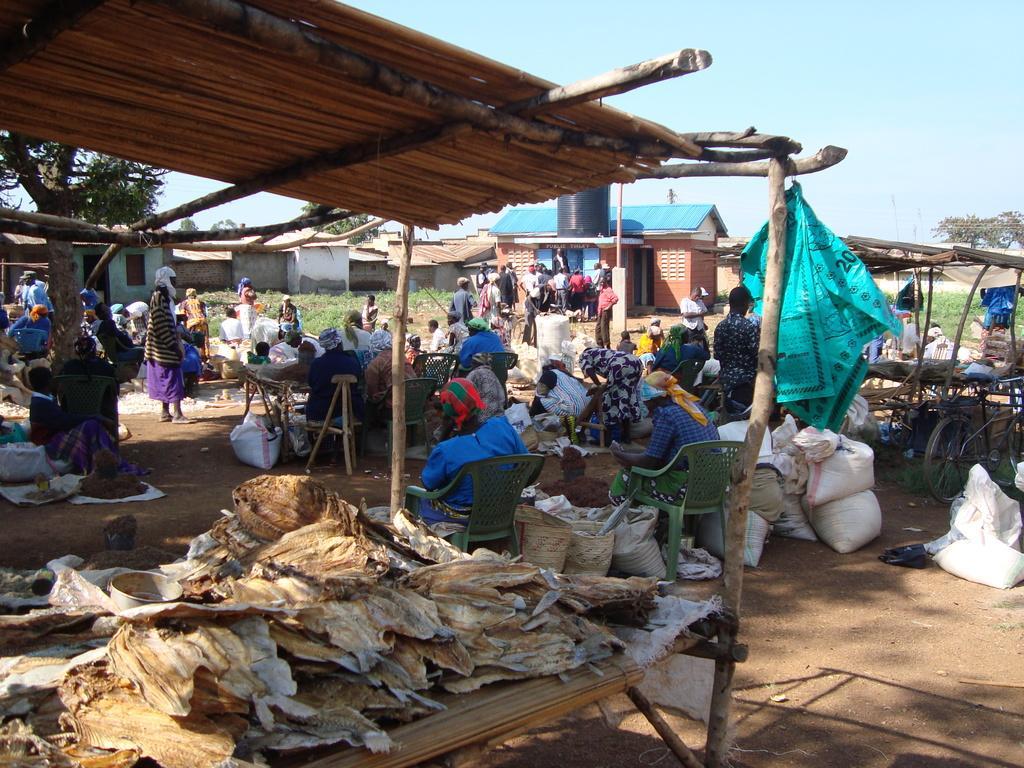How would you summarize this image in a sentence or two? In this picture I can see there are few objects placed on the table and there are few bags placed on the soil and there are few people sitting on the chairs and few of them are standing and there are buildings and trees. The sky is clear. 